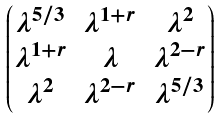Convert formula to latex. <formula><loc_0><loc_0><loc_500><loc_500>\begin{pmatrix} \lambda ^ { 5 / 3 } & \lambda ^ { 1 + r } & \lambda ^ { 2 } \\ \lambda ^ { 1 + r } & \lambda & \lambda ^ { 2 - r } \\ \lambda ^ { 2 } & \lambda ^ { 2 - r } & \lambda ^ { 5 / 3 } \end{pmatrix}</formula> 